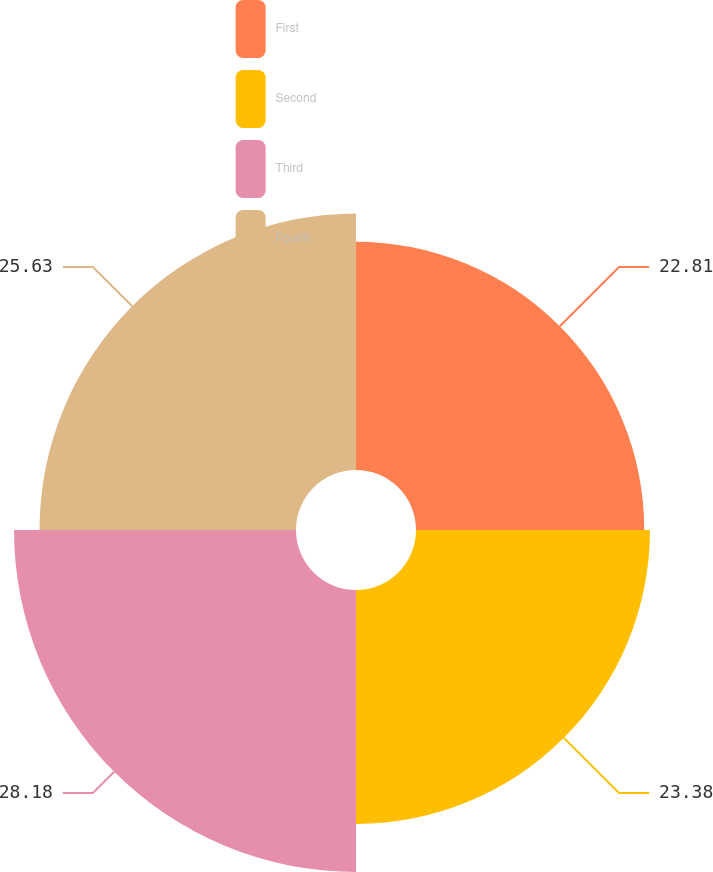Convert chart to OTSL. <chart><loc_0><loc_0><loc_500><loc_500><pie_chart><fcel>First<fcel>Second<fcel>Third<fcel>Fourth<nl><fcel>22.81%<fcel>23.38%<fcel>28.18%<fcel>25.63%<nl></chart> 